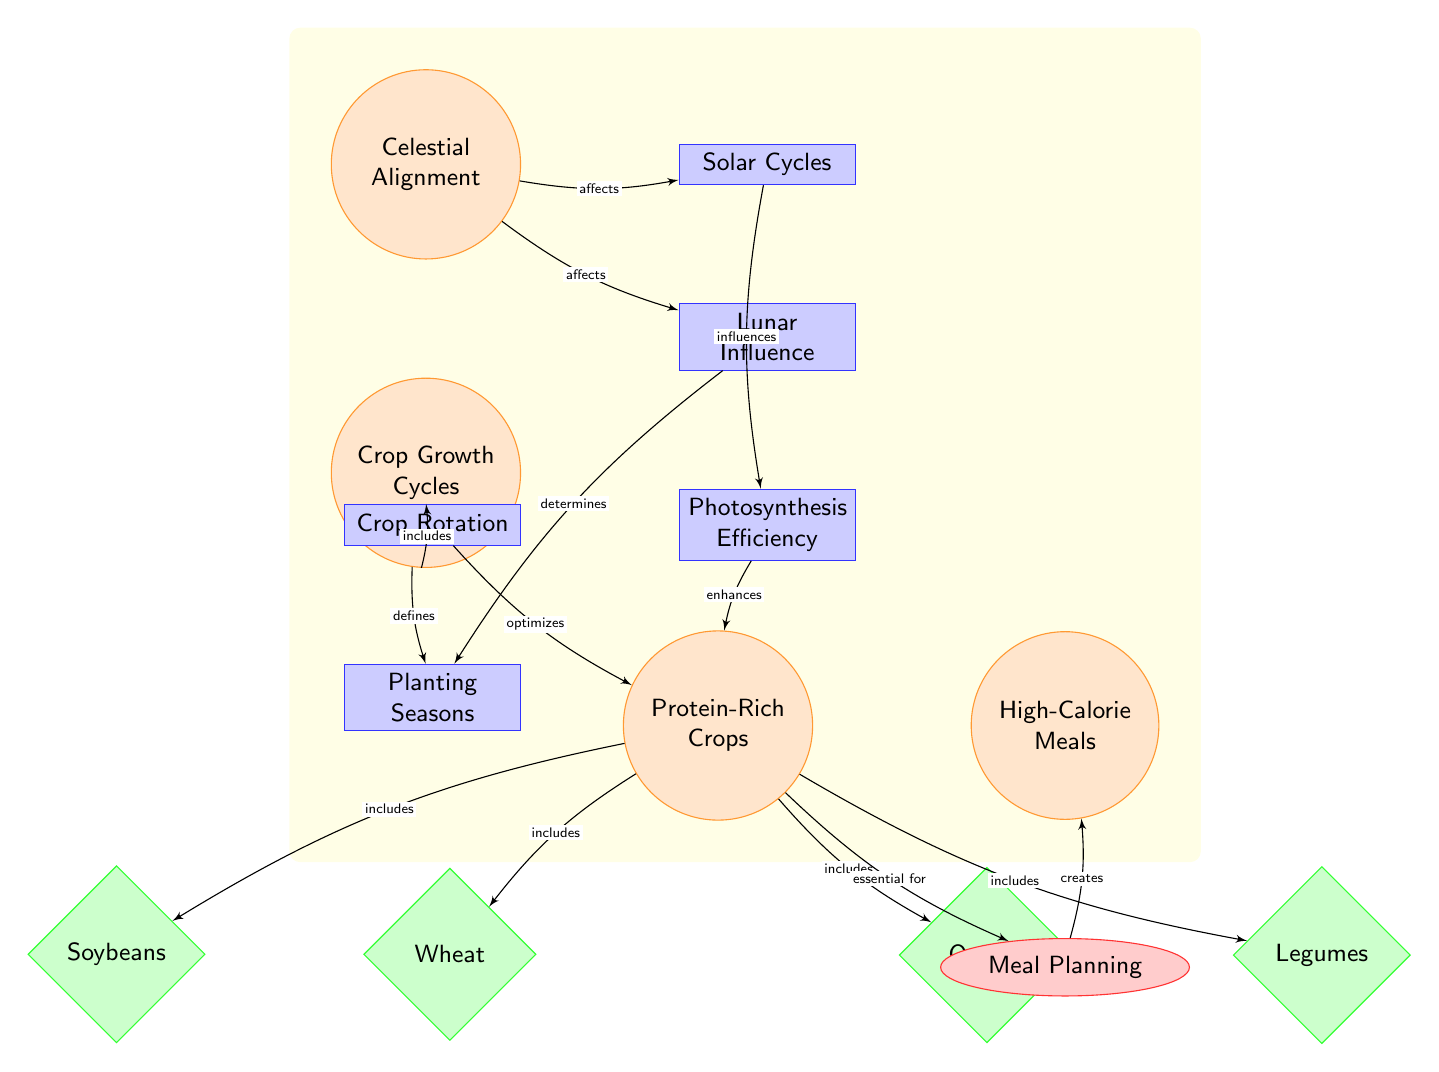What is the main focus of this diagram? The main focus of the diagram is to illustrate the relationship between celestial alignment and crop growth cycles, specifically in maximizing protein yield for high-calorie diets.
Answer: Celestial Alignment How many types of crops are mentioned in the diagram? The diagram lists four types of crops: Wheat, Soybeans, Quinoa, and Legumes, indicating that there are four distinct varieties associated with protein-rich crops.
Answer: Four What process is influenced by solar cycles? According to the diagram, solar cycles influence photosynthesis efficiency, linking the celestial aspect to the plant growth process vital for crop production.
Answer: Photosynthesis Efficiency Which concept defines the timing of planting? The timing of planting is defined by lunar influence, showing how celestial events can affect agricultural practices and schedules.
Answer: Lunar Influence What is essential for meal planning according to the diagram? The diagram indicates that protein-rich crops are essential for meal planning, highlighting the importance of incorporating these crops into high-calorie meals for wrestlers' diets.
Answer: Protein-Rich Crops What effect does crop rotation have on protein-rich crops? The diagram indicates that crop rotation optimizes protein-rich crops, meaning that rotating different crops can enhance the yield and nutritional value of protein sources.
Answer: Optimizes What promotes crop growth cycles? The diagram suggests that celestial alignment promotes crop growth cycles, showing the interconnected nature of astronomy and agriculture.
Answer: Celestial Alignment What is included in high-calorie meals? High-calorie meals include protein-rich crops such as Wheat, Soybeans, Quinoa, and Legumes, demonstrating how nutrition is derived from these crops for dietary needs.
Answer: Protein-Rich Crops 